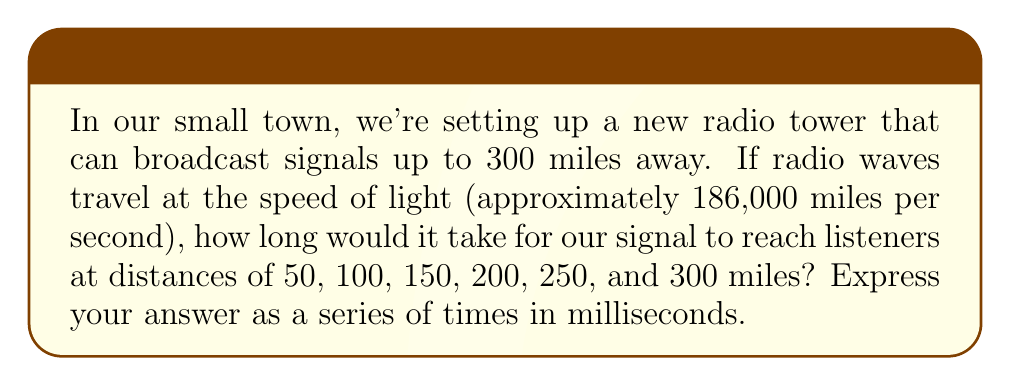Can you solve this math problem? To solve this problem, we'll use the formula:

$$ \text{Time} = \frac{\text{Distance}}{\text{Speed}} $$

Given:
- Speed of radio waves (speed of light) = 186,000 miles/second
- Distances: 50, 100, 150, 200, 250, and 300 miles

Let's calculate the time for each distance:

1) For 50 miles:
   $$ \text{Time} = \frac{50}{186,000} \approx 0.000268817 \text{ seconds} $$
   Convert to milliseconds: $0.000268817 \times 1000 \approx 0.268817 \text{ ms}$

2) For 100 miles:
   $$ \text{Time} = \frac{100}{186,000} \approx 0.000537634 \text{ seconds} \approx 0.537634 \text{ ms} $$

3) For 150 miles:
   $$ \text{Time} = \frac{150}{186,000} \approx 0.000806452 \text{ seconds} \approx 0.806452 \text{ ms} $$

4) For 200 miles:
   $$ \text{Time} = \frac{200}{186,000} \approx 0.001075269 \text{ seconds} \approx 1.075269 \text{ ms} $$

5) For 250 miles:
   $$ \text{Time} = \frac{250}{186,000} \approx 0.001344086 \text{ seconds} \approx 1.344086 \text{ ms} $$

6) For 300 miles:
   $$ \text{Time} = \frac{300}{186,000} \approx 0.001612903 \text{ seconds} \approx 1.612903 \text{ ms} $$

The series of times in milliseconds is:
$$ 0.268817, 0.537634, 0.806452, 1.075269, 1.344086, 1.612903 $$
Answer: 0.268817, 0.537634, 0.806452, 1.075269, 1.344086, 1.612903 ms 